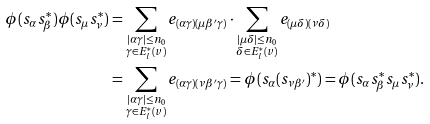Convert formula to latex. <formula><loc_0><loc_0><loc_500><loc_500>\phi ( s _ { \alpha } s _ { \beta } ^ { * } ) \phi ( s _ { \mu } s _ { \nu } ^ { * } ) & = \sum _ { \substack { { | \alpha \gamma | \leq n _ { 0 } } \\ { \gamma \in E _ { l } ^ { * } ( v ) } } } e _ { ( \alpha \gamma ) ( \mu \beta ^ { \prime } \gamma ) } \cdot \sum _ { \substack { { | \mu \delta | \leq n _ { 0 } } \\ { \delta \in E _ { l } ^ { * } ( v ) } } } e _ { ( \mu \delta ) ( \nu \delta ) } \\ & = \sum _ { \substack { { | \alpha \gamma | \leq n _ { 0 } } \\ { \gamma \in E _ { l } ^ { * } ( v ) } } } e _ { ( \alpha \gamma ) ( \nu \beta ^ { \prime } \gamma ) } = \phi ( s _ { \alpha } ( s _ { \nu \beta ^ { \prime } } ) ^ { * } ) = \phi ( s _ { \alpha } s _ { \beta } ^ { * } s _ { \mu } s _ { \nu } ^ { * } ) .</formula> 